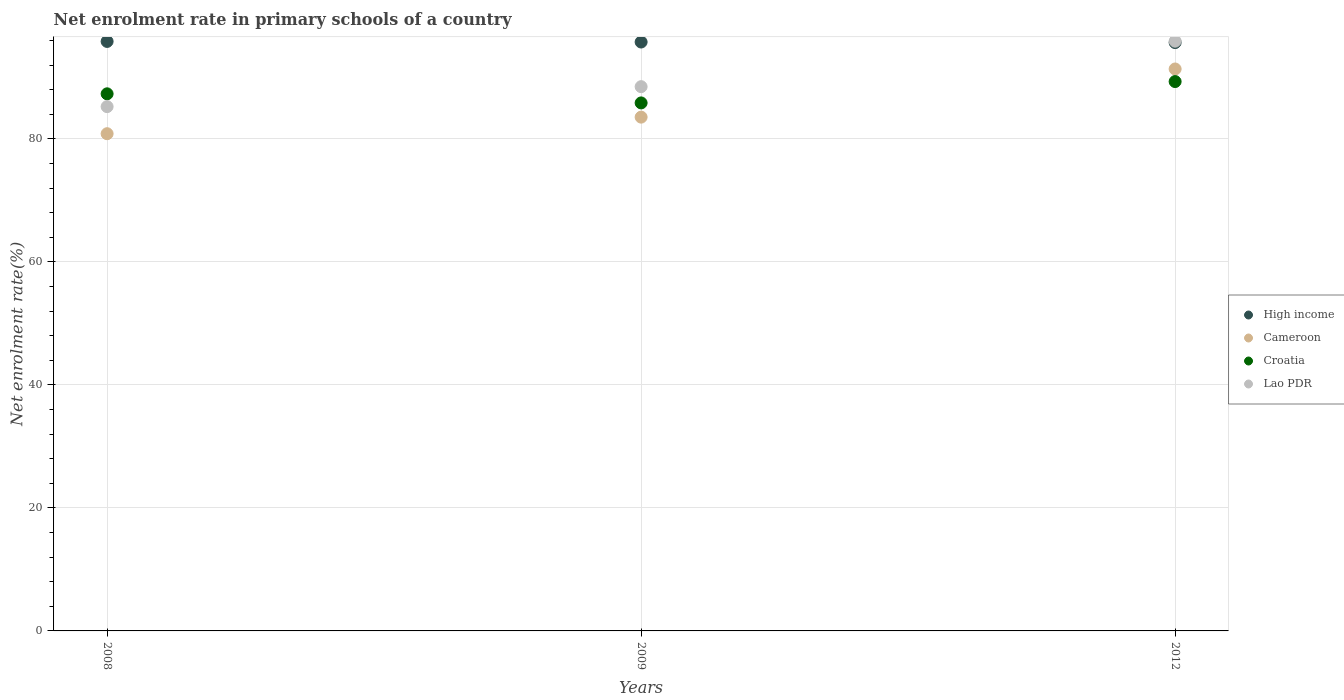What is the net enrolment rate in primary schools in Cameroon in 2012?
Ensure brevity in your answer.  91.36. Across all years, what is the maximum net enrolment rate in primary schools in High income?
Your response must be concise. 95.84. Across all years, what is the minimum net enrolment rate in primary schools in High income?
Offer a very short reply. 95.65. In which year was the net enrolment rate in primary schools in Cameroon minimum?
Your answer should be compact. 2008. What is the total net enrolment rate in primary schools in High income in the graph?
Keep it short and to the point. 287.23. What is the difference between the net enrolment rate in primary schools in Lao PDR in 2009 and that in 2012?
Your answer should be very brief. -7.39. What is the difference between the net enrolment rate in primary schools in Cameroon in 2008 and the net enrolment rate in primary schools in Lao PDR in 2009?
Provide a succinct answer. -7.65. What is the average net enrolment rate in primary schools in Cameroon per year?
Provide a succinct answer. 85.24. In the year 2008, what is the difference between the net enrolment rate in primary schools in High income and net enrolment rate in primary schools in Croatia?
Your answer should be very brief. 8.52. In how many years, is the net enrolment rate in primary schools in Croatia greater than 20 %?
Offer a very short reply. 3. What is the ratio of the net enrolment rate in primary schools in High income in 2008 to that in 2009?
Ensure brevity in your answer.  1. What is the difference between the highest and the second highest net enrolment rate in primary schools in High income?
Keep it short and to the point. 0.1. What is the difference between the highest and the lowest net enrolment rate in primary schools in High income?
Give a very brief answer. 0.19. Is the sum of the net enrolment rate in primary schools in Croatia in 2009 and 2012 greater than the maximum net enrolment rate in primary schools in Lao PDR across all years?
Your answer should be compact. Yes. Is it the case that in every year, the sum of the net enrolment rate in primary schools in Cameroon and net enrolment rate in primary schools in Croatia  is greater than the net enrolment rate in primary schools in Lao PDR?
Offer a terse response. Yes. Is the net enrolment rate in primary schools in High income strictly greater than the net enrolment rate in primary schools in Lao PDR over the years?
Your answer should be compact. No. How many dotlines are there?
Offer a terse response. 4. Are the values on the major ticks of Y-axis written in scientific E-notation?
Offer a very short reply. No. Does the graph contain grids?
Offer a very short reply. Yes. Where does the legend appear in the graph?
Offer a terse response. Center right. How many legend labels are there?
Offer a terse response. 4. What is the title of the graph?
Offer a terse response. Net enrolment rate in primary schools of a country. Does "Greece" appear as one of the legend labels in the graph?
Offer a very short reply. No. What is the label or title of the Y-axis?
Keep it short and to the point. Net enrolment rate(%). What is the Net enrolment rate(%) in High income in 2008?
Provide a succinct answer. 95.84. What is the Net enrolment rate(%) of Cameroon in 2008?
Provide a short and direct response. 80.84. What is the Net enrolment rate(%) of Croatia in 2008?
Provide a short and direct response. 87.32. What is the Net enrolment rate(%) of Lao PDR in 2008?
Keep it short and to the point. 85.24. What is the Net enrolment rate(%) in High income in 2009?
Provide a short and direct response. 95.74. What is the Net enrolment rate(%) of Cameroon in 2009?
Provide a succinct answer. 83.53. What is the Net enrolment rate(%) of Croatia in 2009?
Your answer should be compact. 85.84. What is the Net enrolment rate(%) of Lao PDR in 2009?
Offer a terse response. 88.49. What is the Net enrolment rate(%) of High income in 2012?
Your answer should be very brief. 95.65. What is the Net enrolment rate(%) in Cameroon in 2012?
Your answer should be very brief. 91.36. What is the Net enrolment rate(%) in Croatia in 2012?
Provide a short and direct response. 89.32. What is the Net enrolment rate(%) in Lao PDR in 2012?
Your answer should be very brief. 95.88. Across all years, what is the maximum Net enrolment rate(%) of High income?
Keep it short and to the point. 95.84. Across all years, what is the maximum Net enrolment rate(%) in Cameroon?
Your answer should be very brief. 91.36. Across all years, what is the maximum Net enrolment rate(%) in Croatia?
Provide a succinct answer. 89.32. Across all years, what is the maximum Net enrolment rate(%) in Lao PDR?
Provide a short and direct response. 95.88. Across all years, what is the minimum Net enrolment rate(%) of High income?
Offer a terse response. 95.65. Across all years, what is the minimum Net enrolment rate(%) in Cameroon?
Keep it short and to the point. 80.84. Across all years, what is the minimum Net enrolment rate(%) in Croatia?
Offer a very short reply. 85.84. Across all years, what is the minimum Net enrolment rate(%) of Lao PDR?
Provide a succinct answer. 85.24. What is the total Net enrolment rate(%) in High income in the graph?
Keep it short and to the point. 287.23. What is the total Net enrolment rate(%) in Cameroon in the graph?
Make the answer very short. 255.73. What is the total Net enrolment rate(%) in Croatia in the graph?
Ensure brevity in your answer.  262.48. What is the total Net enrolment rate(%) of Lao PDR in the graph?
Provide a short and direct response. 269.6. What is the difference between the Net enrolment rate(%) in High income in 2008 and that in 2009?
Your response must be concise. 0.1. What is the difference between the Net enrolment rate(%) in Cameroon in 2008 and that in 2009?
Give a very brief answer. -2.69. What is the difference between the Net enrolment rate(%) in Croatia in 2008 and that in 2009?
Make the answer very short. 1.48. What is the difference between the Net enrolment rate(%) of Lao PDR in 2008 and that in 2009?
Provide a short and direct response. -3.25. What is the difference between the Net enrolment rate(%) of High income in 2008 and that in 2012?
Your response must be concise. 0.19. What is the difference between the Net enrolment rate(%) of Cameroon in 2008 and that in 2012?
Your response must be concise. -10.52. What is the difference between the Net enrolment rate(%) of Croatia in 2008 and that in 2012?
Ensure brevity in your answer.  -1.99. What is the difference between the Net enrolment rate(%) of Lao PDR in 2008 and that in 2012?
Provide a short and direct response. -10.64. What is the difference between the Net enrolment rate(%) of High income in 2009 and that in 2012?
Ensure brevity in your answer.  0.09. What is the difference between the Net enrolment rate(%) in Cameroon in 2009 and that in 2012?
Your answer should be very brief. -7.83. What is the difference between the Net enrolment rate(%) in Croatia in 2009 and that in 2012?
Offer a very short reply. -3.47. What is the difference between the Net enrolment rate(%) of Lao PDR in 2009 and that in 2012?
Offer a terse response. -7.39. What is the difference between the Net enrolment rate(%) in High income in 2008 and the Net enrolment rate(%) in Cameroon in 2009?
Provide a succinct answer. 12.31. What is the difference between the Net enrolment rate(%) in High income in 2008 and the Net enrolment rate(%) in Croatia in 2009?
Provide a short and direct response. 10. What is the difference between the Net enrolment rate(%) of High income in 2008 and the Net enrolment rate(%) of Lao PDR in 2009?
Provide a succinct answer. 7.35. What is the difference between the Net enrolment rate(%) in Cameroon in 2008 and the Net enrolment rate(%) in Croatia in 2009?
Make the answer very short. -5. What is the difference between the Net enrolment rate(%) of Cameroon in 2008 and the Net enrolment rate(%) of Lao PDR in 2009?
Make the answer very short. -7.65. What is the difference between the Net enrolment rate(%) of Croatia in 2008 and the Net enrolment rate(%) of Lao PDR in 2009?
Give a very brief answer. -1.16. What is the difference between the Net enrolment rate(%) in High income in 2008 and the Net enrolment rate(%) in Cameroon in 2012?
Offer a very short reply. 4.48. What is the difference between the Net enrolment rate(%) in High income in 2008 and the Net enrolment rate(%) in Croatia in 2012?
Make the answer very short. 6.52. What is the difference between the Net enrolment rate(%) in High income in 2008 and the Net enrolment rate(%) in Lao PDR in 2012?
Provide a succinct answer. -0.04. What is the difference between the Net enrolment rate(%) in Cameroon in 2008 and the Net enrolment rate(%) in Croatia in 2012?
Give a very brief answer. -8.48. What is the difference between the Net enrolment rate(%) of Cameroon in 2008 and the Net enrolment rate(%) of Lao PDR in 2012?
Keep it short and to the point. -15.04. What is the difference between the Net enrolment rate(%) in Croatia in 2008 and the Net enrolment rate(%) in Lao PDR in 2012?
Offer a terse response. -8.56. What is the difference between the Net enrolment rate(%) in High income in 2009 and the Net enrolment rate(%) in Cameroon in 2012?
Offer a very short reply. 4.38. What is the difference between the Net enrolment rate(%) in High income in 2009 and the Net enrolment rate(%) in Croatia in 2012?
Provide a short and direct response. 6.43. What is the difference between the Net enrolment rate(%) of High income in 2009 and the Net enrolment rate(%) of Lao PDR in 2012?
Ensure brevity in your answer.  -0.13. What is the difference between the Net enrolment rate(%) in Cameroon in 2009 and the Net enrolment rate(%) in Croatia in 2012?
Your answer should be very brief. -5.78. What is the difference between the Net enrolment rate(%) of Cameroon in 2009 and the Net enrolment rate(%) of Lao PDR in 2012?
Offer a terse response. -12.34. What is the difference between the Net enrolment rate(%) in Croatia in 2009 and the Net enrolment rate(%) in Lao PDR in 2012?
Keep it short and to the point. -10.03. What is the average Net enrolment rate(%) of High income per year?
Give a very brief answer. 95.74. What is the average Net enrolment rate(%) in Cameroon per year?
Give a very brief answer. 85.24. What is the average Net enrolment rate(%) of Croatia per year?
Provide a succinct answer. 87.49. What is the average Net enrolment rate(%) of Lao PDR per year?
Provide a succinct answer. 89.87. In the year 2008, what is the difference between the Net enrolment rate(%) of High income and Net enrolment rate(%) of Cameroon?
Give a very brief answer. 15. In the year 2008, what is the difference between the Net enrolment rate(%) of High income and Net enrolment rate(%) of Croatia?
Make the answer very short. 8.52. In the year 2008, what is the difference between the Net enrolment rate(%) of High income and Net enrolment rate(%) of Lao PDR?
Make the answer very short. 10.6. In the year 2008, what is the difference between the Net enrolment rate(%) of Cameroon and Net enrolment rate(%) of Croatia?
Your answer should be very brief. -6.48. In the year 2008, what is the difference between the Net enrolment rate(%) of Cameroon and Net enrolment rate(%) of Lao PDR?
Make the answer very short. -4.4. In the year 2008, what is the difference between the Net enrolment rate(%) of Croatia and Net enrolment rate(%) of Lao PDR?
Keep it short and to the point. 2.08. In the year 2009, what is the difference between the Net enrolment rate(%) of High income and Net enrolment rate(%) of Cameroon?
Your response must be concise. 12.21. In the year 2009, what is the difference between the Net enrolment rate(%) of High income and Net enrolment rate(%) of Lao PDR?
Offer a terse response. 7.26. In the year 2009, what is the difference between the Net enrolment rate(%) in Cameroon and Net enrolment rate(%) in Croatia?
Offer a terse response. -2.31. In the year 2009, what is the difference between the Net enrolment rate(%) in Cameroon and Net enrolment rate(%) in Lao PDR?
Offer a very short reply. -4.95. In the year 2009, what is the difference between the Net enrolment rate(%) of Croatia and Net enrolment rate(%) of Lao PDR?
Your answer should be very brief. -2.64. In the year 2012, what is the difference between the Net enrolment rate(%) in High income and Net enrolment rate(%) in Cameroon?
Your answer should be compact. 4.29. In the year 2012, what is the difference between the Net enrolment rate(%) of High income and Net enrolment rate(%) of Croatia?
Give a very brief answer. 6.34. In the year 2012, what is the difference between the Net enrolment rate(%) of High income and Net enrolment rate(%) of Lao PDR?
Give a very brief answer. -0.22. In the year 2012, what is the difference between the Net enrolment rate(%) of Cameroon and Net enrolment rate(%) of Croatia?
Offer a very short reply. 2.04. In the year 2012, what is the difference between the Net enrolment rate(%) in Cameroon and Net enrolment rate(%) in Lao PDR?
Offer a terse response. -4.52. In the year 2012, what is the difference between the Net enrolment rate(%) in Croatia and Net enrolment rate(%) in Lao PDR?
Keep it short and to the point. -6.56. What is the ratio of the Net enrolment rate(%) of High income in 2008 to that in 2009?
Ensure brevity in your answer.  1. What is the ratio of the Net enrolment rate(%) in Croatia in 2008 to that in 2009?
Provide a succinct answer. 1.02. What is the ratio of the Net enrolment rate(%) of Lao PDR in 2008 to that in 2009?
Give a very brief answer. 0.96. What is the ratio of the Net enrolment rate(%) of Cameroon in 2008 to that in 2012?
Your answer should be very brief. 0.88. What is the ratio of the Net enrolment rate(%) of Croatia in 2008 to that in 2012?
Provide a succinct answer. 0.98. What is the ratio of the Net enrolment rate(%) of Lao PDR in 2008 to that in 2012?
Give a very brief answer. 0.89. What is the ratio of the Net enrolment rate(%) in High income in 2009 to that in 2012?
Offer a very short reply. 1. What is the ratio of the Net enrolment rate(%) in Cameroon in 2009 to that in 2012?
Your answer should be very brief. 0.91. What is the ratio of the Net enrolment rate(%) in Croatia in 2009 to that in 2012?
Your response must be concise. 0.96. What is the ratio of the Net enrolment rate(%) in Lao PDR in 2009 to that in 2012?
Provide a succinct answer. 0.92. What is the difference between the highest and the second highest Net enrolment rate(%) in High income?
Give a very brief answer. 0.1. What is the difference between the highest and the second highest Net enrolment rate(%) of Cameroon?
Your answer should be very brief. 7.83. What is the difference between the highest and the second highest Net enrolment rate(%) of Croatia?
Your answer should be compact. 1.99. What is the difference between the highest and the second highest Net enrolment rate(%) of Lao PDR?
Offer a very short reply. 7.39. What is the difference between the highest and the lowest Net enrolment rate(%) of High income?
Offer a very short reply. 0.19. What is the difference between the highest and the lowest Net enrolment rate(%) of Cameroon?
Your answer should be compact. 10.52. What is the difference between the highest and the lowest Net enrolment rate(%) in Croatia?
Provide a succinct answer. 3.47. What is the difference between the highest and the lowest Net enrolment rate(%) in Lao PDR?
Offer a very short reply. 10.64. 